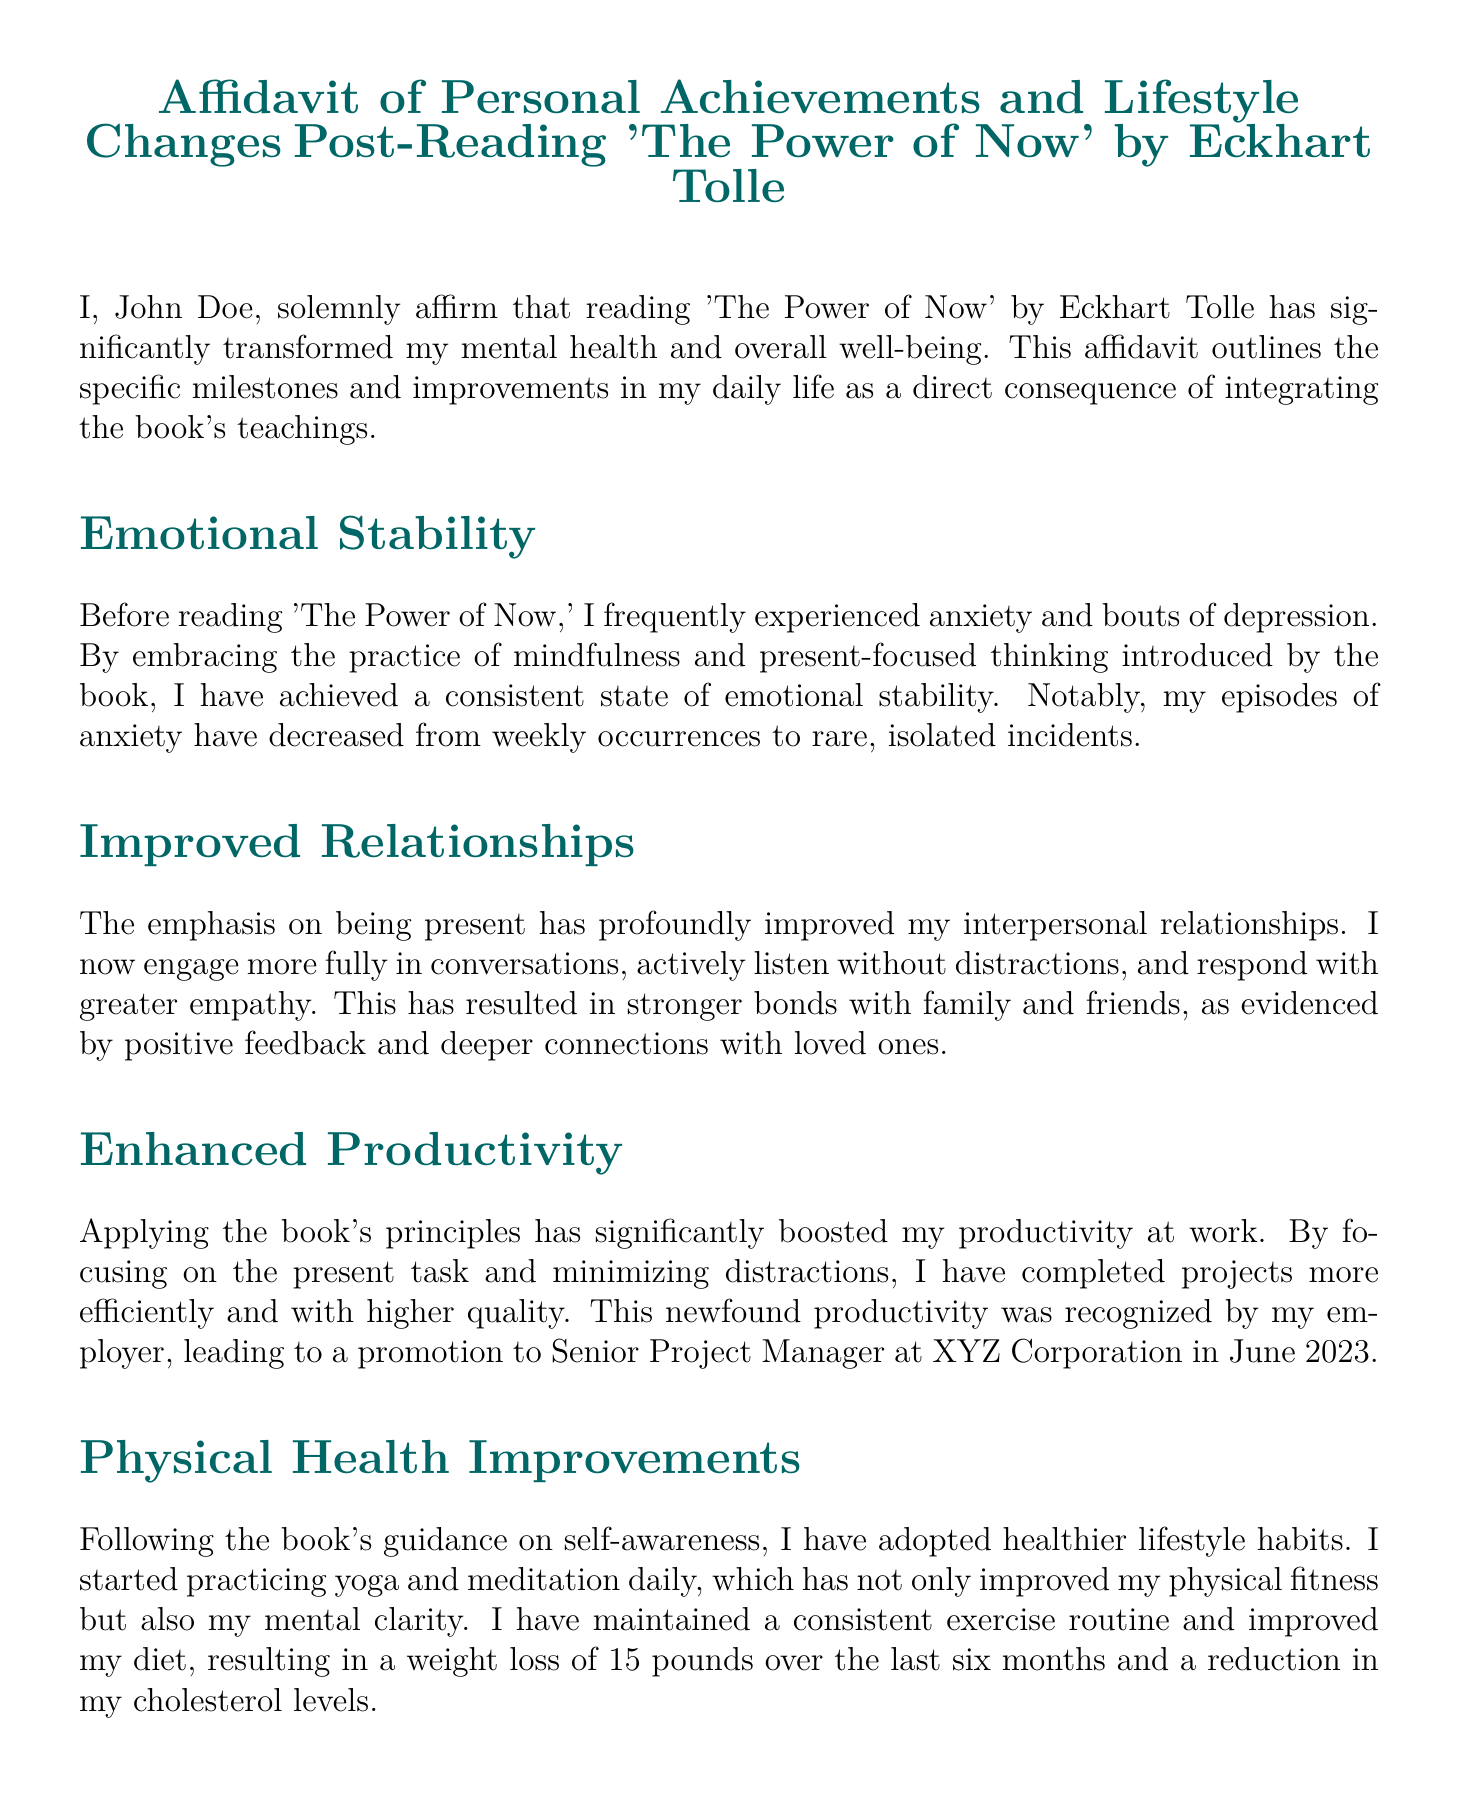What book is the affidavit based on? The affidavit discusses the impact of reading 'The Power of Now' by Eckhart Tolle.
Answer: 'The Power of Now' Who is the author of the book mentioned in the affidavit? The affidavit states that the book was written by Eckhart Tolle.
Answer: Eckhart Tolle What significant change in emotional stability is noted in the affidavit? The affidavit indicates that episodes of anxiety have decreased from weekly occurrences to rare, isolated incidents.
Answer: Rare, isolated incidents When was the promotion to Senior Project Manager achieved? The affidavit specifies that the promotion was recognized in June 2023.
Answer: June 2023 How much weight was lost following the book's guidance? The affidavit states a weight loss of 15 pounds over the last six months.
Answer: 15 pounds What new business was started as a result of increased self-confidence? The affidavit mentions the business 'Mindful Creations' focused on promoting mindfulness through creative arts.
Answer: Mindful Creations What physical activities were adopted according to the affidavit? The affidavit states that yoga and meditation practices were adopted daily.
Answer: Yoga and meditation What milestone in relationships is highlighted in the affidavit? The affidavit describes that the author now engages more fully in conversations and listens actively without distractions.
Answer: Stronger bonds with family and friends What was the impact of the book on productivity? The affidavit states that the principles boosted productivity, leading to more efficient and higher quality work.
Answer: Boosted productivity 